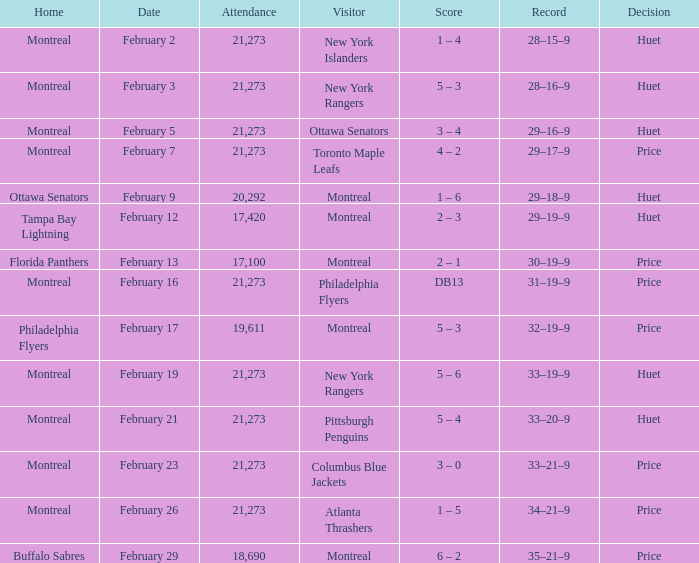Who was the visiting team at the game when the Canadiens had a record of 30–19–9? Montreal. Parse the full table. {'header': ['Home', 'Date', 'Attendance', 'Visitor', 'Score', 'Record', 'Decision'], 'rows': [['Montreal', 'February 2', '21,273', 'New York Islanders', '1 – 4', '28–15–9', 'Huet'], ['Montreal', 'February 3', '21,273', 'New York Rangers', '5 – 3', '28–16–9', 'Huet'], ['Montreal', 'February 5', '21,273', 'Ottawa Senators', '3 – 4', '29–16–9', 'Huet'], ['Montreal', 'February 7', '21,273', 'Toronto Maple Leafs', '4 – 2', '29–17–9', 'Price'], ['Ottawa Senators', 'February 9', '20,292', 'Montreal', '1 – 6', '29–18–9', 'Huet'], ['Tampa Bay Lightning', 'February 12', '17,420', 'Montreal', '2 – 3', '29–19–9', 'Huet'], ['Florida Panthers', 'February 13', '17,100', 'Montreal', '2 – 1', '30–19–9', 'Price'], ['Montreal', 'February 16', '21,273', 'Philadelphia Flyers', 'DB13', '31–19–9', 'Price'], ['Philadelphia Flyers', 'February 17', '19,611', 'Montreal', '5 – 3', '32–19–9', 'Price'], ['Montreal', 'February 19', '21,273', 'New York Rangers', '5 – 6', '33–19–9', 'Huet'], ['Montreal', 'February 21', '21,273', 'Pittsburgh Penguins', '5 – 4', '33–20–9', 'Huet'], ['Montreal', 'February 23', '21,273', 'Columbus Blue Jackets', '3 – 0', '33–21–9', 'Price'], ['Montreal', 'February 26', '21,273', 'Atlanta Thrashers', '1 – 5', '34–21–9', 'Price'], ['Buffalo Sabres', 'February 29', '18,690', 'Montreal', '6 – 2', '35–21–9', 'Price']]} 